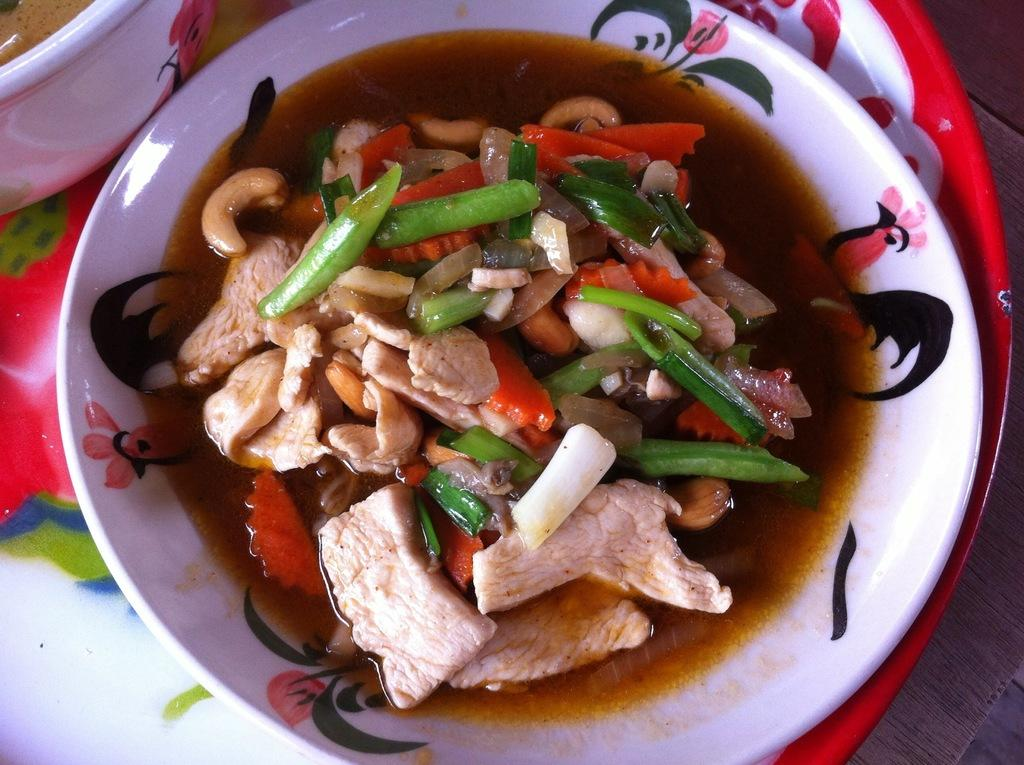What is placed in a bowl in the image? There is an eatable item placed in a bowl in the image. Can you see the grandmother feeding the robin with sticks in the image? There is no grandmother, robin, or sticks present in the image. 